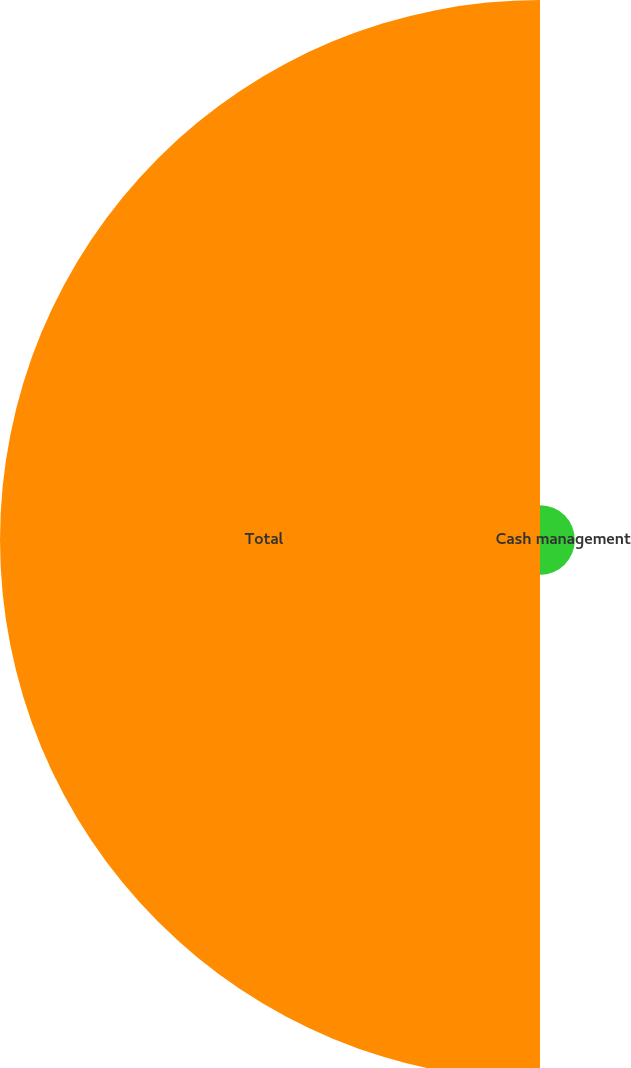Convert chart to OTSL. <chart><loc_0><loc_0><loc_500><loc_500><pie_chart><fcel>Cash management<fcel>Total<nl><fcel>6.06%<fcel>93.94%<nl></chart> 